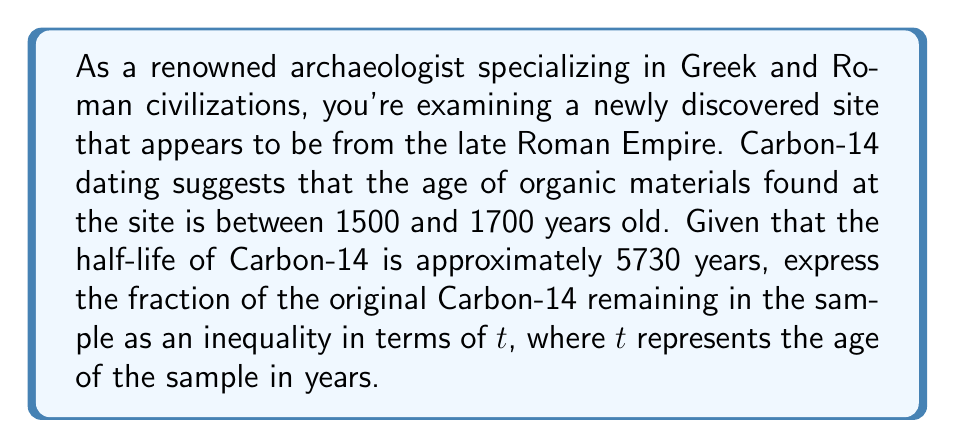Give your solution to this math problem. To solve this problem, we need to use the radioactive decay formula and convert the given age range into an inequality expression. Let's approach this step-by-step:

1) The radioactive decay formula is:

   $$N(t) = N_0 \cdot (1/2)^{t/t_{1/2}}$$

   Where:
   $N(t)$ is the amount remaining after time $t$
   $N_0$ is the initial amount
   $t$ is the time elapsed
   $t_{1/2}$ is the half-life

2) We want to express the fraction of the original amount remaining, which is $N(t)/N_0$. This gives us:

   $$\frac{N(t)}{N_0} = (1/2)^{t/t_{1/2}}$$

3) We know that $t_{1/2} = 5730$ years for Carbon-14. Substituting this:

   $$\frac{N(t)}{N_0} = (1/2)^{t/5730}$$

4) Now, we need to express the age range (1500 to 1700 years) as an inequality:

   $$1500 \leq t \leq 1700$$

5) We can convert this into two separate inequalities for the fraction remaining:

   $$(1/2)^{1700/5730} \leq (1/2)^{t/5730} \leq (1/2)^{1500/5730}$$

   Note that the inequality signs are reversed for the left side because the exponential function with base 1/2 is decreasing.

6) Calculating the values:

   $$(1/2)^{1700/5730} \approx 0.7948$$
   $$(1/2)^{1500/5730} \approx 0.8160$$

Therefore, our final inequality expression is:

$$0.7948 \leq (1/2)^{t/5730} \leq 0.8160$$
Answer: $$0.7948 \leq (1/2)^{t/5730} \leq 0.8160$$ 